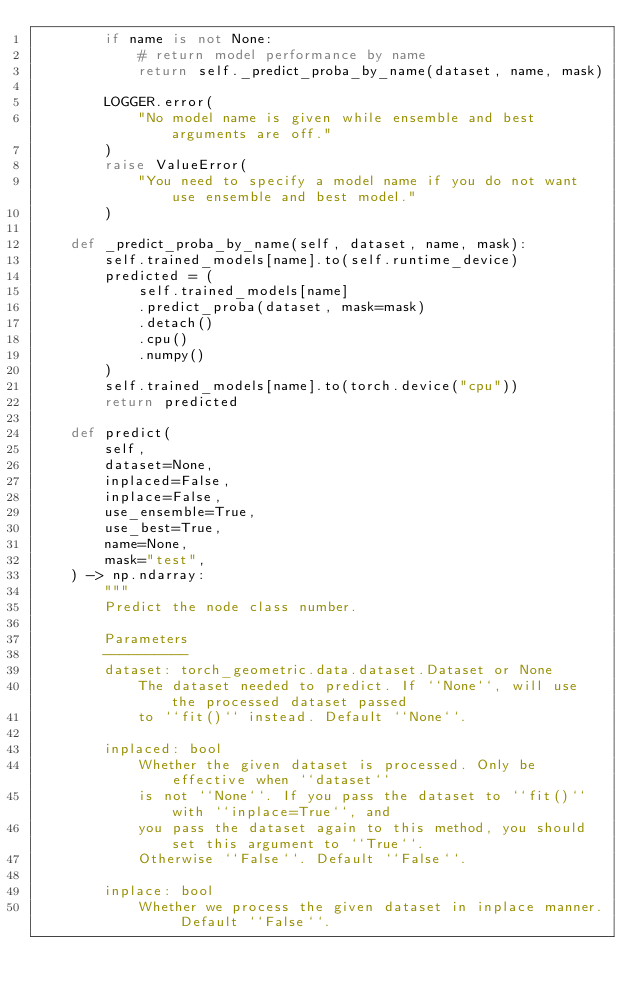<code> <loc_0><loc_0><loc_500><loc_500><_Python_>        if name is not None:
            # return model performance by name
            return self._predict_proba_by_name(dataset, name, mask)

        LOGGER.error(
            "No model name is given while ensemble and best arguments are off."
        )
        raise ValueError(
            "You need to specify a model name if you do not want use ensemble and best model."
        )

    def _predict_proba_by_name(self, dataset, name, mask):
        self.trained_models[name].to(self.runtime_device)
        predicted = (
            self.trained_models[name]
            .predict_proba(dataset, mask=mask)
            .detach()
            .cpu()
            .numpy()
        )
        self.trained_models[name].to(torch.device("cpu"))
        return predicted

    def predict(
        self,
        dataset=None,
        inplaced=False,
        inplace=False,
        use_ensemble=True,
        use_best=True,
        name=None,
        mask="test",
    ) -> np.ndarray:
        """
        Predict the node class number.

        Parameters
        ----------
        dataset: torch_geometric.data.dataset.Dataset or None
            The dataset needed to predict. If ``None``, will use the processed dataset passed
            to ``fit()`` instead. Default ``None``.

        inplaced: bool
            Whether the given dataset is processed. Only be effective when ``dataset``
            is not ``None``. If you pass the dataset to ``fit()`` with ``inplace=True``, and
            you pass the dataset again to this method, you should set this argument to ``True``.
            Otherwise ``False``. Default ``False``.

        inplace: bool
            Whether we process the given dataset in inplace manner. Default ``False``.</code> 